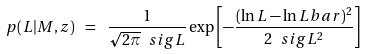<formula> <loc_0><loc_0><loc_500><loc_500>p ( L | M , z ) \ = \ \frac { 1 } { \sqrt { 2 \pi } \ s i g L } \exp \left [ - \frac { ( \ln L - \ln L b a r ) ^ { 2 } } { 2 \ s i g L ^ { 2 } } \right ]</formula> 